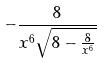Convert formula to latex. <formula><loc_0><loc_0><loc_500><loc_500>- \frac { 8 } { x ^ { 6 } \sqrt { 8 - \frac { 8 } { x ^ { 6 } } } }</formula> 